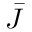<formula> <loc_0><loc_0><loc_500><loc_500>\bar { J }</formula> 